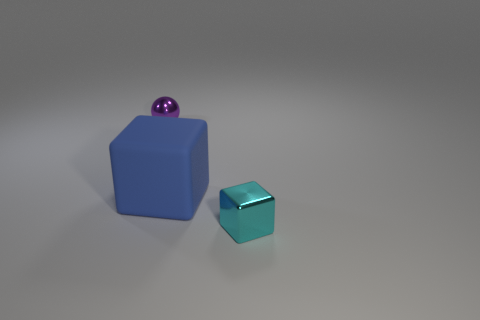Are there any other things that are the same size as the purple metal sphere?
Provide a succinct answer. Yes. Is the number of purple rubber cubes less than the number of matte objects?
Provide a succinct answer. Yes. There is a object that is in front of the purple metal thing and to the left of the tiny shiny cube; what is its shape?
Provide a succinct answer. Cube. How many big metal cubes are there?
Provide a short and direct response. 0. What is the material of the small thing that is in front of the tiny metallic object that is behind the block to the right of the blue block?
Offer a terse response. Metal. What number of purple objects are behind the shiny object that is in front of the purple sphere?
Your answer should be compact. 1. There is another metallic thing that is the same shape as the big object; what is its color?
Offer a terse response. Cyan. Do the large blue object and the tiny cyan cube have the same material?
Ensure brevity in your answer.  No. How many blocks are either purple metal objects or cyan metallic things?
Offer a terse response. 1. What size is the block on the left side of the small metallic thing on the right side of the tiny metallic thing on the left side of the big blue matte cube?
Offer a terse response. Large. 